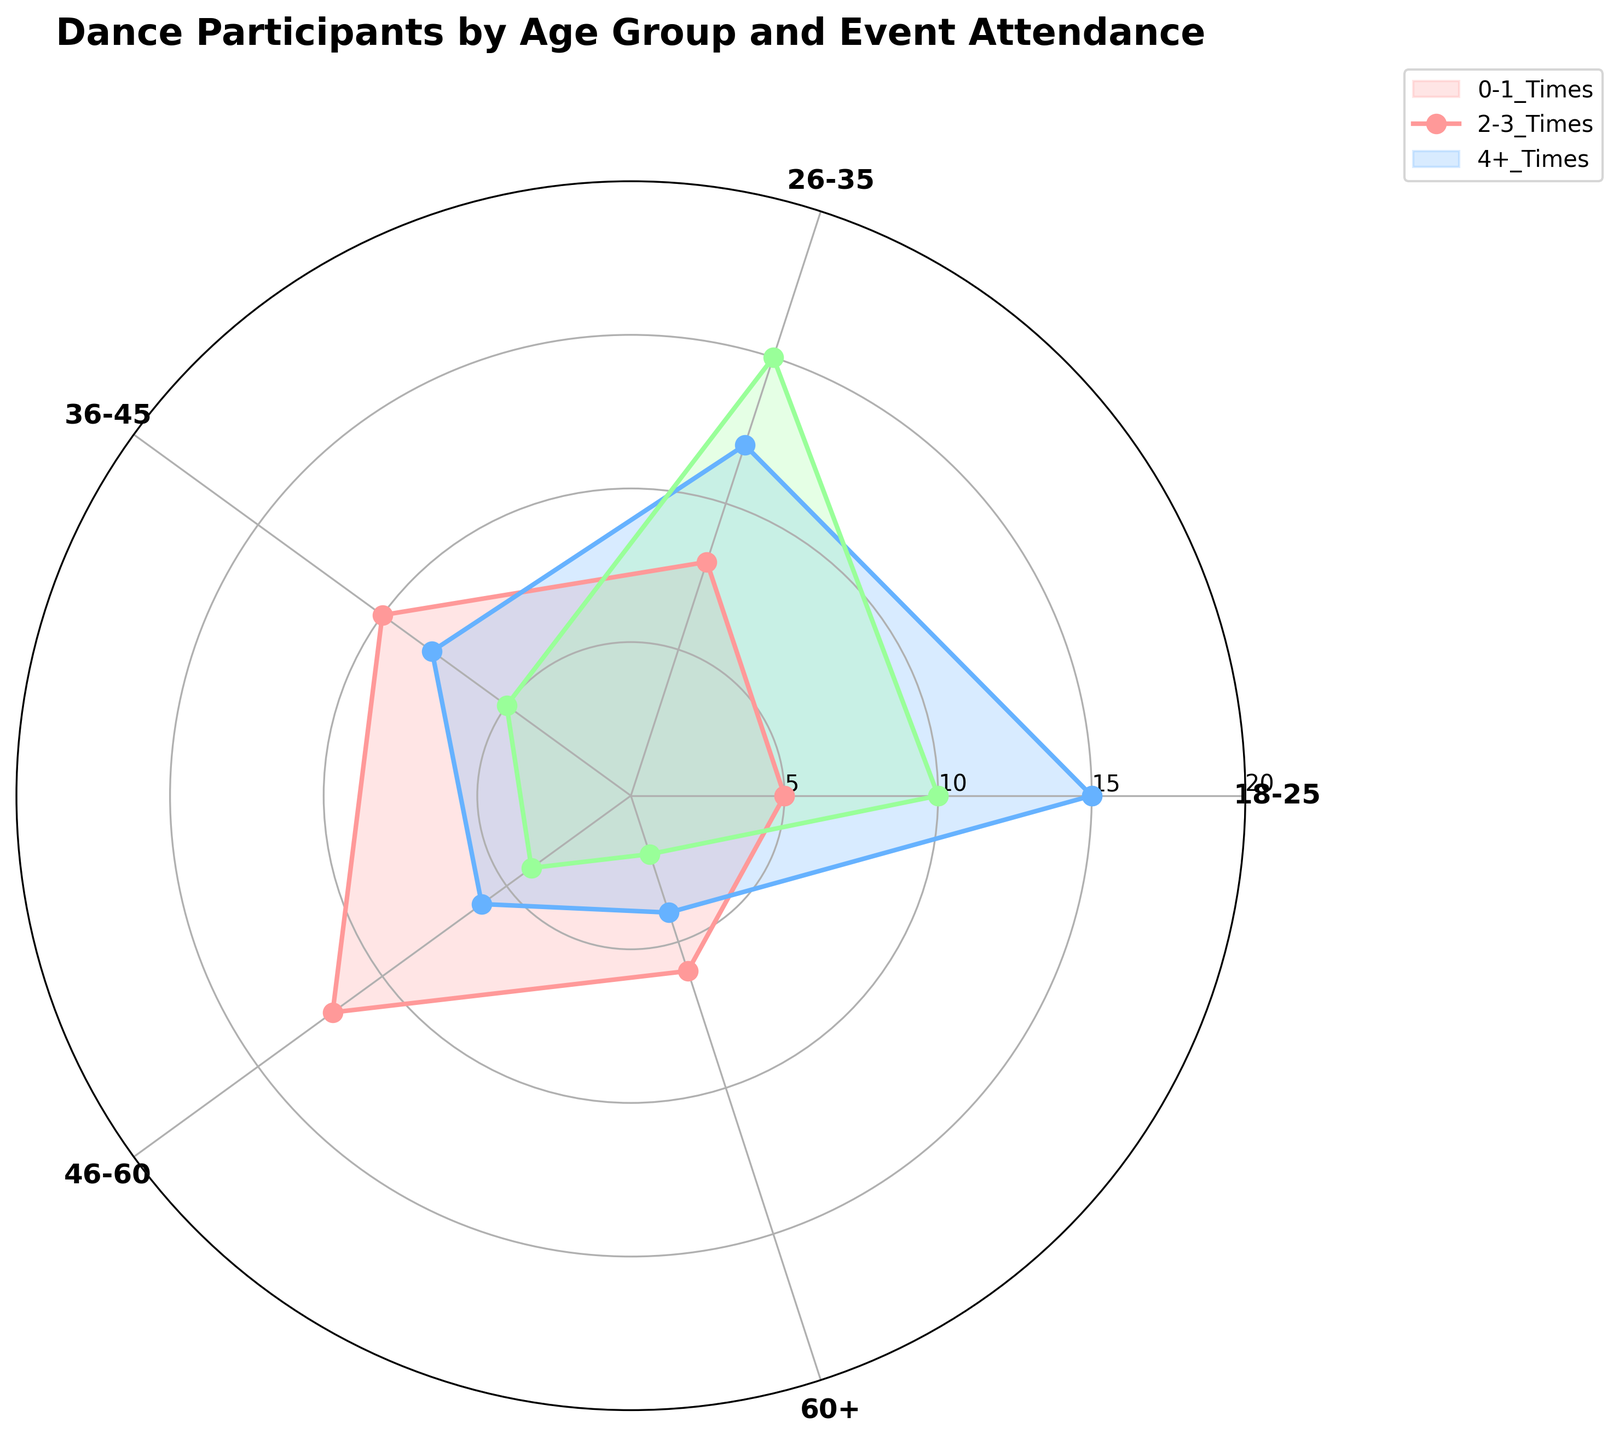What is the title of the chart? The title can be found at the top of the chart.
Answer: Dance Participants by Age Group and Event Attendance Which age group has the highest attendance at 4+ times events? Look at the data for the 4+ Times frequency and see which age group's segment extends the furthest from the center of the polar plot.
Answer: 26-35 For the 18-25 age group, how does the attendance for 2-3 times compare to the attendance for 0-1 times? Compare the lengths of the segments for the 18-25 age group for both the 2-3 Times and 0-1 Times frequencies. The segment for 2-3 Times is longer.
Answer: 2-3 Times is higher What is the total attendance for all age groups in the 0-1 times category? Sum the values for all age groups in the 0-1 Times category: 5 (18-25) + 8 (26-35) + 10 (36-45) + 12 (46-60) + 6 (60+).
Answer: 41 Which frequency shows the least variation across all age groups? Evaluate the range of variations for each frequency. The one with the smallest differences in segment lengths has the least variation.
Answer: 4+ Times Which age group has the lowest attendance in the 4+ times category? Look at the data for the 4+ Times frequency and see which age group's segment is the shortest in the polar plot.
Answer: 60+ How do the attendance patterns for the 36-45 and 46-60 age groups differ? Compare the segments for both age groups across all frequencies: 0-1 Times, 2-3 Times, and 4+ Times. The 36-45 group has higher on 0-1 Times and lower on 2-3 Times and 4+ Times compared to the 46-60 group.
Answer: 36-45 has more 0-1 Times, 46-60 has more 2-3 and 4+ Times What's the average number of participants for the 26-35 age group across all attendance frequencies? Sum the values for the 26-35 age group across all frequencies and divide by the number of categories: (8 + 12 + 15) / 3.
Answer: 11.67 In what frequency category does the 60+ age group show the highest attendance? Compare the segment lengths for the 60+ age group across all frequencies. The 0-1 Times segment is the longest.
Answer: 0-1 Times 